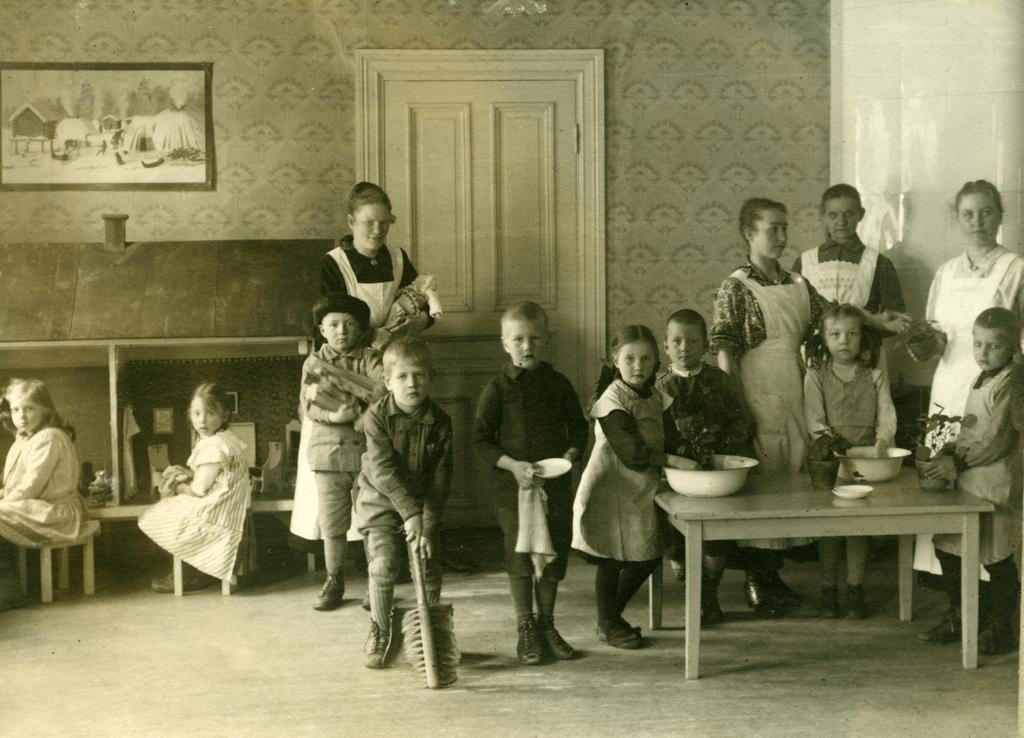In one or two sentences, can you explain what this image depicts? This picture is taken inside the room. Here, we see many children standing and playing inside the room. On the right corner of the picture, we see a table on which two bowls and small plate are placed and the two children are placing their hands in that bowl and playing. Behind them, we see three women standing and behind these people, we see a wall and a white door and on wall, we see a photo frame. 